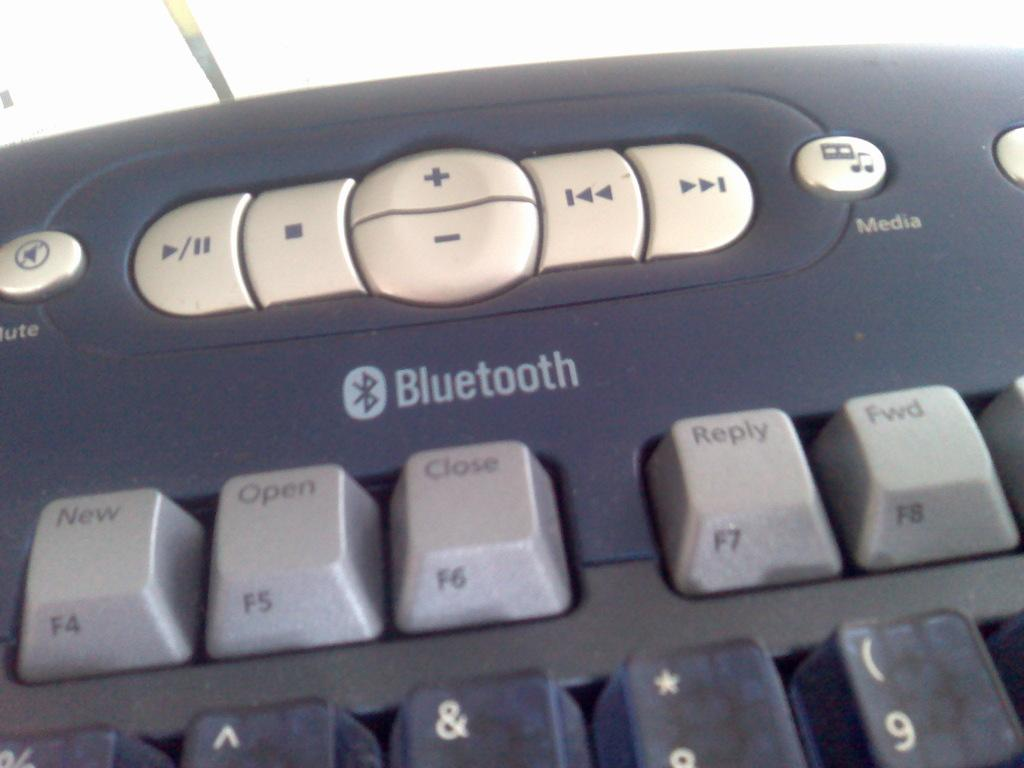<image>
Write a terse but informative summary of the picture. A dark grey keyboard which is bluetooth enabled. 